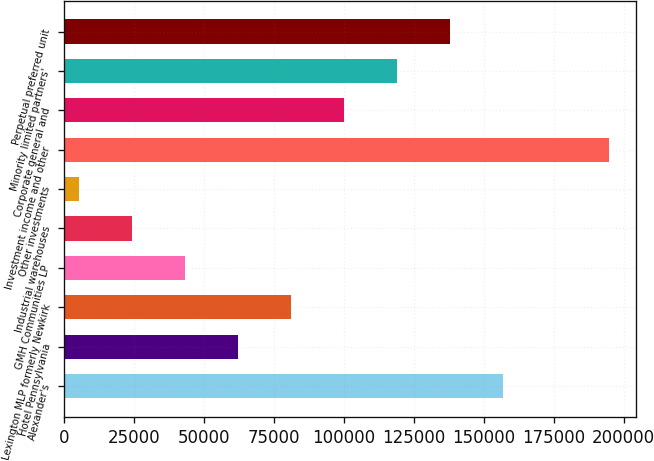<chart> <loc_0><loc_0><loc_500><loc_500><bar_chart><fcel>Alexander's<fcel>Hotel Pennsylvania<fcel>Lexington MLP formerly Newkirk<fcel>GMH Communities LP<fcel>Industrial warehouses<fcel>Other investments<fcel>Investment income and other<fcel>Corporate general and<fcel>Minority limited partners'<fcel>Perpetual preferred unit<nl><fcel>156945<fcel>62178.6<fcel>81131.8<fcel>43225.4<fcel>24272.2<fcel>5319<fcel>194851<fcel>100085<fcel>119038<fcel>137991<nl></chart> 